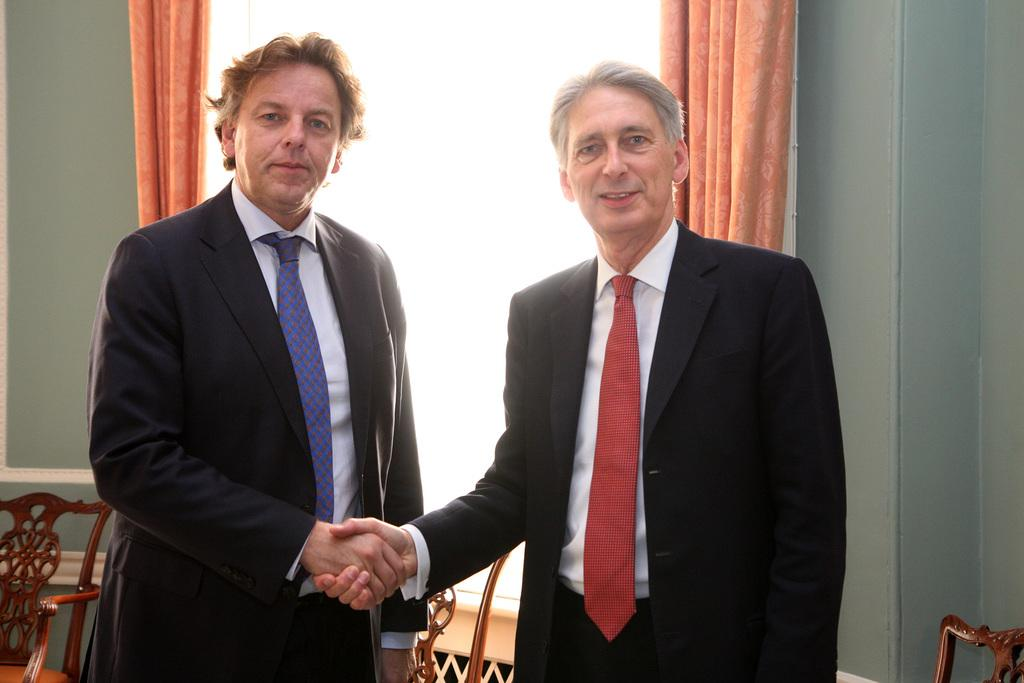How many men are present in the image? There are two men in the image. What are the men wearing? The men are wearing suits. What are the men doing in the image? The men are watching each other and shaking hands. What can be seen in the background of the image? There is a wall, curtains, and chairs in the background of the image. What type of crack can be heard in the image? There is no crack or sound present in the image; it is a still photograph. 